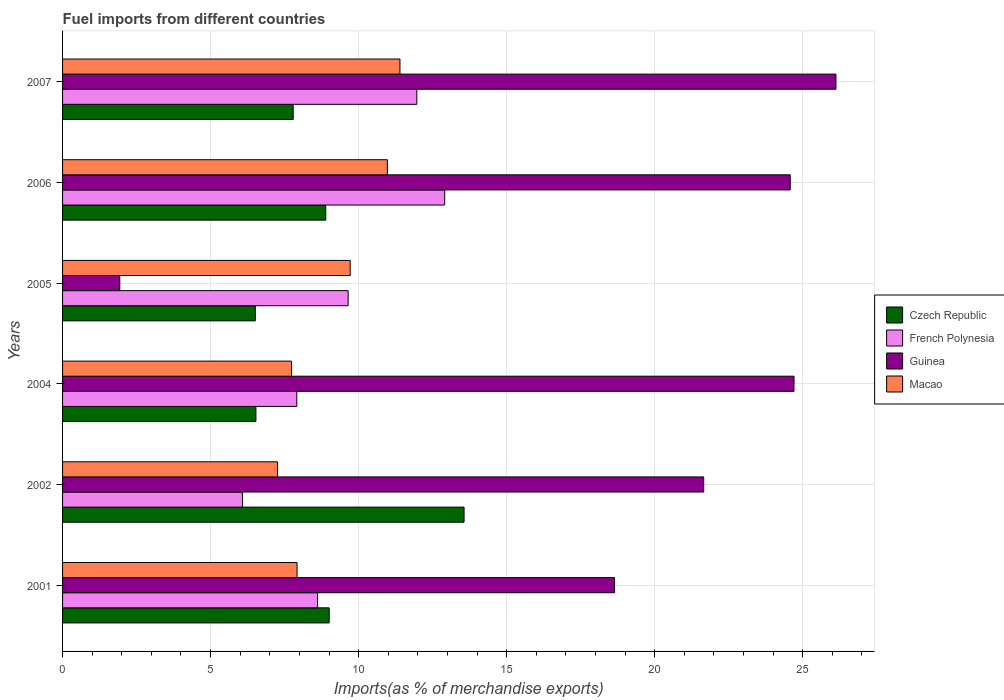How many groups of bars are there?
Your response must be concise. 6. Are the number of bars per tick equal to the number of legend labels?
Provide a short and direct response. Yes. What is the label of the 5th group of bars from the top?
Offer a very short reply. 2002. What is the percentage of imports to different countries in Macao in 2007?
Provide a succinct answer. 11.4. Across all years, what is the maximum percentage of imports to different countries in Guinea?
Your answer should be very brief. 26.12. Across all years, what is the minimum percentage of imports to different countries in Czech Republic?
Keep it short and to the point. 6.51. In which year was the percentage of imports to different countries in Czech Republic maximum?
Your answer should be compact. 2002. In which year was the percentage of imports to different countries in Czech Republic minimum?
Ensure brevity in your answer.  2005. What is the total percentage of imports to different countries in Guinea in the graph?
Ensure brevity in your answer.  117.65. What is the difference between the percentage of imports to different countries in Czech Republic in 2001 and that in 2005?
Offer a terse response. 2.5. What is the difference between the percentage of imports to different countries in Czech Republic in 2006 and the percentage of imports to different countries in French Polynesia in 2002?
Keep it short and to the point. 2.81. What is the average percentage of imports to different countries in French Polynesia per year?
Offer a very short reply. 9.52. In the year 2002, what is the difference between the percentage of imports to different countries in Macao and percentage of imports to different countries in Czech Republic?
Offer a very short reply. -6.3. In how many years, is the percentage of imports to different countries in French Polynesia greater than 16 %?
Give a very brief answer. 0. What is the ratio of the percentage of imports to different countries in Czech Republic in 2001 to that in 2005?
Keep it short and to the point. 1.38. Is the percentage of imports to different countries in French Polynesia in 2004 less than that in 2007?
Ensure brevity in your answer.  Yes. Is the difference between the percentage of imports to different countries in Macao in 2001 and 2006 greater than the difference between the percentage of imports to different countries in Czech Republic in 2001 and 2006?
Give a very brief answer. No. What is the difference between the highest and the second highest percentage of imports to different countries in Guinea?
Keep it short and to the point. 1.42. What is the difference between the highest and the lowest percentage of imports to different countries in Guinea?
Ensure brevity in your answer.  24.19. In how many years, is the percentage of imports to different countries in Macao greater than the average percentage of imports to different countries in Macao taken over all years?
Keep it short and to the point. 3. What does the 2nd bar from the top in 2002 represents?
Your answer should be compact. Guinea. What does the 4th bar from the bottom in 2004 represents?
Keep it short and to the point. Macao. Is it the case that in every year, the sum of the percentage of imports to different countries in Guinea and percentage of imports to different countries in Czech Republic is greater than the percentage of imports to different countries in French Polynesia?
Provide a succinct answer. No. What is the difference between two consecutive major ticks on the X-axis?
Give a very brief answer. 5. Are the values on the major ticks of X-axis written in scientific E-notation?
Your answer should be very brief. No. Where does the legend appear in the graph?
Provide a succinct answer. Center right. How are the legend labels stacked?
Give a very brief answer. Vertical. What is the title of the graph?
Give a very brief answer. Fuel imports from different countries. What is the label or title of the X-axis?
Ensure brevity in your answer.  Imports(as % of merchandise exports). What is the label or title of the Y-axis?
Offer a very short reply. Years. What is the Imports(as % of merchandise exports) in Czech Republic in 2001?
Make the answer very short. 9.01. What is the Imports(as % of merchandise exports) in French Polynesia in 2001?
Make the answer very short. 8.61. What is the Imports(as % of merchandise exports) in Guinea in 2001?
Your answer should be very brief. 18.65. What is the Imports(as % of merchandise exports) in Macao in 2001?
Give a very brief answer. 7.92. What is the Imports(as % of merchandise exports) in Czech Republic in 2002?
Ensure brevity in your answer.  13.56. What is the Imports(as % of merchandise exports) of French Polynesia in 2002?
Provide a short and direct response. 6.08. What is the Imports(as % of merchandise exports) in Guinea in 2002?
Your answer should be very brief. 21.66. What is the Imports(as % of merchandise exports) of Macao in 2002?
Your response must be concise. 7.26. What is the Imports(as % of merchandise exports) of Czech Republic in 2004?
Provide a short and direct response. 6.53. What is the Imports(as % of merchandise exports) of French Polynesia in 2004?
Keep it short and to the point. 7.91. What is the Imports(as % of merchandise exports) of Guinea in 2004?
Your answer should be very brief. 24.71. What is the Imports(as % of merchandise exports) in Macao in 2004?
Make the answer very short. 7.74. What is the Imports(as % of merchandise exports) in Czech Republic in 2005?
Ensure brevity in your answer.  6.51. What is the Imports(as % of merchandise exports) in French Polynesia in 2005?
Offer a terse response. 9.65. What is the Imports(as % of merchandise exports) in Guinea in 2005?
Ensure brevity in your answer.  1.93. What is the Imports(as % of merchandise exports) in Macao in 2005?
Make the answer very short. 9.72. What is the Imports(as % of merchandise exports) of Czech Republic in 2006?
Your answer should be very brief. 8.89. What is the Imports(as % of merchandise exports) of French Polynesia in 2006?
Make the answer very short. 12.91. What is the Imports(as % of merchandise exports) in Guinea in 2006?
Provide a succinct answer. 24.58. What is the Imports(as % of merchandise exports) in Macao in 2006?
Provide a succinct answer. 10.97. What is the Imports(as % of merchandise exports) of Czech Republic in 2007?
Your response must be concise. 7.79. What is the Imports(as % of merchandise exports) of French Polynesia in 2007?
Your answer should be very brief. 11.97. What is the Imports(as % of merchandise exports) in Guinea in 2007?
Offer a terse response. 26.12. What is the Imports(as % of merchandise exports) of Macao in 2007?
Provide a succinct answer. 11.4. Across all years, what is the maximum Imports(as % of merchandise exports) of Czech Republic?
Provide a short and direct response. 13.56. Across all years, what is the maximum Imports(as % of merchandise exports) of French Polynesia?
Offer a terse response. 12.91. Across all years, what is the maximum Imports(as % of merchandise exports) in Guinea?
Offer a very short reply. 26.12. Across all years, what is the maximum Imports(as % of merchandise exports) of Macao?
Ensure brevity in your answer.  11.4. Across all years, what is the minimum Imports(as % of merchandise exports) of Czech Republic?
Give a very brief answer. 6.51. Across all years, what is the minimum Imports(as % of merchandise exports) of French Polynesia?
Offer a very short reply. 6.08. Across all years, what is the minimum Imports(as % of merchandise exports) of Guinea?
Make the answer very short. 1.93. Across all years, what is the minimum Imports(as % of merchandise exports) in Macao?
Your response must be concise. 7.26. What is the total Imports(as % of merchandise exports) of Czech Republic in the graph?
Keep it short and to the point. 52.29. What is the total Imports(as % of merchandise exports) of French Polynesia in the graph?
Provide a short and direct response. 57.12. What is the total Imports(as % of merchandise exports) in Guinea in the graph?
Offer a terse response. 117.65. What is the total Imports(as % of merchandise exports) of Macao in the graph?
Your response must be concise. 55. What is the difference between the Imports(as % of merchandise exports) of Czech Republic in 2001 and that in 2002?
Provide a succinct answer. -4.56. What is the difference between the Imports(as % of merchandise exports) in French Polynesia in 2001 and that in 2002?
Keep it short and to the point. 2.54. What is the difference between the Imports(as % of merchandise exports) of Guinea in 2001 and that in 2002?
Your response must be concise. -3.01. What is the difference between the Imports(as % of merchandise exports) of Macao in 2001 and that in 2002?
Provide a short and direct response. 0.66. What is the difference between the Imports(as % of merchandise exports) of Czech Republic in 2001 and that in 2004?
Provide a succinct answer. 2.48. What is the difference between the Imports(as % of merchandise exports) in French Polynesia in 2001 and that in 2004?
Keep it short and to the point. 0.7. What is the difference between the Imports(as % of merchandise exports) of Guinea in 2001 and that in 2004?
Provide a succinct answer. -6.06. What is the difference between the Imports(as % of merchandise exports) of Macao in 2001 and that in 2004?
Your response must be concise. 0.18. What is the difference between the Imports(as % of merchandise exports) in Czech Republic in 2001 and that in 2005?
Keep it short and to the point. 2.5. What is the difference between the Imports(as % of merchandise exports) in French Polynesia in 2001 and that in 2005?
Your answer should be compact. -1.03. What is the difference between the Imports(as % of merchandise exports) in Guinea in 2001 and that in 2005?
Give a very brief answer. 16.71. What is the difference between the Imports(as % of merchandise exports) in Macao in 2001 and that in 2005?
Offer a terse response. -1.79. What is the difference between the Imports(as % of merchandise exports) of Czech Republic in 2001 and that in 2006?
Make the answer very short. 0.12. What is the difference between the Imports(as % of merchandise exports) in French Polynesia in 2001 and that in 2006?
Keep it short and to the point. -4.3. What is the difference between the Imports(as % of merchandise exports) in Guinea in 2001 and that in 2006?
Keep it short and to the point. -5.93. What is the difference between the Imports(as % of merchandise exports) in Macao in 2001 and that in 2006?
Keep it short and to the point. -3.05. What is the difference between the Imports(as % of merchandise exports) of Czech Republic in 2001 and that in 2007?
Provide a succinct answer. 1.22. What is the difference between the Imports(as % of merchandise exports) in French Polynesia in 2001 and that in 2007?
Give a very brief answer. -3.35. What is the difference between the Imports(as % of merchandise exports) of Guinea in 2001 and that in 2007?
Keep it short and to the point. -7.48. What is the difference between the Imports(as % of merchandise exports) in Macao in 2001 and that in 2007?
Your response must be concise. -3.48. What is the difference between the Imports(as % of merchandise exports) of Czech Republic in 2002 and that in 2004?
Your answer should be compact. 7.03. What is the difference between the Imports(as % of merchandise exports) of French Polynesia in 2002 and that in 2004?
Ensure brevity in your answer.  -1.83. What is the difference between the Imports(as % of merchandise exports) of Guinea in 2002 and that in 2004?
Provide a short and direct response. -3.05. What is the difference between the Imports(as % of merchandise exports) in Macao in 2002 and that in 2004?
Your answer should be compact. -0.47. What is the difference between the Imports(as % of merchandise exports) of Czech Republic in 2002 and that in 2005?
Keep it short and to the point. 7.05. What is the difference between the Imports(as % of merchandise exports) in French Polynesia in 2002 and that in 2005?
Offer a terse response. -3.57. What is the difference between the Imports(as % of merchandise exports) in Guinea in 2002 and that in 2005?
Provide a succinct answer. 19.72. What is the difference between the Imports(as % of merchandise exports) of Macao in 2002 and that in 2005?
Provide a short and direct response. -2.45. What is the difference between the Imports(as % of merchandise exports) of Czech Republic in 2002 and that in 2006?
Make the answer very short. 4.67. What is the difference between the Imports(as % of merchandise exports) in French Polynesia in 2002 and that in 2006?
Keep it short and to the point. -6.83. What is the difference between the Imports(as % of merchandise exports) of Guinea in 2002 and that in 2006?
Provide a short and direct response. -2.92. What is the difference between the Imports(as % of merchandise exports) of Macao in 2002 and that in 2006?
Offer a very short reply. -3.71. What is the difference between the Imports(as % of merchandise exports) of Czech Republic in 2002 and that in 2007?
Keep it short and to the point. 5.77. What is the difference between the Imports(as % of merchandise exports) of French Polynesia in 2002 and that in 2007?
Ensure brevity in your answer.  -5.89. What is the difference between the Imports(as % of merchandise exports) of Guinea in 2002 and that in 2007?
Offer a very short reply. -4.47. What is the difference between the Imports(as % of merchandise exports) in Macao in 2002 and that in 2007?
Offer a terse response. -4.13. What is the difference between the Imports(as % of merchandise exports) of Czech Republic in 2004 and that in 2005?
Keep it short and to the point. 0.02. What is the difference between the Imports(as % of merchandise exports) of French Polynesia in 2004 and that in 2005?
Offer a very short reply. -1.73. What is the difference between the Imports(as % of merchandise exports) in Guinea in 2004 and that in 2005?
Your answer should be very brief. 22.78. What is the difference between the Imports(as % of merchandise exports) of Macao in 2004 and that in 2005?
Offer a very short reply. -1.98. What is the difference between the Imports(as % of merchandise exports) in Czech Republic in 2004 and that in 2006?
Offer a terse response. -2.36. What is the difference between the Imports(as % of merchandise exports) of French Polynesia in 2004 and that in 2006?
Give a very brief answer. -5. What is the difference between the Imports(as % of merchandise exports) of Guinea in 2004 and that in 2006?
Offer a very short reply. 0.13. What is the difference between the Imports(as % of merchandise exports) in Macao in 2004 and that in 2006?
Give a very brief answer. -3.24. What is the difference between the Imports(as % of merchandise exports) of Czech Republic in 2004 and that in 2007?
Ensure brevity in your answer.  -1.26. What is the difference between the Imports(as % of merchandise exports) of French Polynesia in 2004 and that in 2007?
Offer a very short reply. -4.05. What is the difference between the Imports(as % of merchandise exports) in Guinea in 2004 and that in 2007?
Your response must be concise. -1.42. What is the difference between the Imports(as % of merchandise exports) of Macao in 2004 and that in 2007?
Give a very brief answer. -3.66. What is the difference between the Imports(as % of merchandise exports) of Czech Republic in 2005 and that in 2006?
Give a very brief answer. -2.38. What is the difference between the Imports(as % of merchandise exports) of French Polynesia in 2005 and that in 2006?
Make the answer very short. -3.26. What is the difference between the Imports(as % of merchandise exports) of Guinea in 2005 and that in 2006?
Your response must be concise. -22.65. What is the difference between the Imports(as % of merchandise exports) of Macao in 2005 and that in 2006?
Make the answer very short. -1.26. What is the difference between the Imports(as % of merchandise exports) in Czech Republic in 2005 and that in 2007?
Ensure brevity in your answer.  -1.28. What is the difference between the Imports(as % of merchandise exports) of French Polynesia in 2005 and that in 2007?
Your response must be concise. -2.32. What is the difference between the Imports(as % of merchandise exports) of Guinea in 2005 and that in 2007?
Offer a very short reply. -24.19. What is the difference between the Imports(as % of merchandise exports) in Macao in 2005 and that in 2007?
Provide a succinct answer. -1.68. What is the difference between the Imports(as % of merchandise exports) in Czech Republic in 2006 and that in 2007?
Your answer should be very brief. 1.1. What is the difference between the Imports(as % of merchandise exports) of French Polynesia in 2006 and that in 2007?
Offer a terse response. 0.94. What is the difference between the Imports(as % of merchandise exports) of Guinea in 2006 and that in 2007?
Ensure brevity in your answer.  -1.54. What is the difference between the Imports(as % of merchandise exports) of Macao in 2006 and that in 2007?
Your response must be concise. -0.43. What is the difference between the Imports(as % of merchandise exports) in Czech Republic in 2001 and the Imports(as % of merchandise exports) in French Polynesia in 2002?
Make the answer very short. 2.93. What is the difference between the Imports(as % of merchandise exports) of Czech Republic in 2001 and the Imports(as % of merchandise exports) of Guinea in 2002?
Provide a succinct answer. -12.65. What is the difference between the Imports(as % of merchandise exports) in Czech Republic in 2001 and the Imports(as % of merchandise exports) in Macao in 2002?
Provide a succinct answer. 1.74. What is the difference between the Imports(as % of merchandise exports) of French Polynesia in 2001 and the Imports(as % of merchandise exports) of Guinea in 2002?
Keep it short and to the point. -13.04. What is the difference between the Imports(as % of merchandise exports) of French Polynesia in 2001 and the Imports(as % of merchandise exports) of Macao in 2002?
Provide a succinct answer. 1.35. What is the difference between the Imports(as % of merchandise exports) of Guinea in 2001 and the Imports(as % of merchandise exports) of Macao in 2002?
Make the answer very short. 11.38. What is the difference between the Imports(as % of merchandise exports) in Czech Republic in 2001 and the Imports(as % of merchandise exports) in French Polynesia in 2004?
Offer a very short reply. 1.09. What is the difference between the Imports(as % of merchandise exports) in Czech Republic in 2001 and the Imports(as % of merchandise exports) in Guinea in 2004?
Keep it short and to the point. -15.7. What is the difference between the Imports(as % of merchandise exports) in Czech Republic in 2001 and the Imports(as % of merchandise exports) in Macao in 2004?
Your answer should be very brief. 1.27. What is the difference between the Imports(as % of merchandise exports) of French Polynesia in 2001 and the Imports(as % of merchandise exports) of Guinea in 2004?
Provide a succinct answer. -16.1. What is the difference between the Imports(as % of merchandise exports) of French Polynesia in 2001 and the Imports(as % of merchandise exports) of Macao in 2004?
Offer a terse response. 0.88. What is the difference between the Imports(as % of merchandise exports) in Guinea in 2001 and the Imports(as % of merchandise exports) in Macao in 2004?
Make the answer very short. 10.91. What is the difference between the Imports(as % of merchandise exports) in Czech Republic in 2001 and the Imports(as % of merchandise exports) in French Polynesia in 2005?
Your response must be concise. -0.64. What is the difference between the Imports(as % of merchandise exports) in Czech Republic in 2001 and the Imports(as % of merchandise exports) in Guinea in 2005?
Your response must be concise. 7.07. What is the difference between the Imports(as % of merchandise exports) of Czech Republic in 2001 and the Imports(as % of merchandise exports) of Macao in 2005?
Give a very brief answer. -0.71. What is the difference between the Imports(as % of merchandise exports) of French Polynesia in 2001 and the Imports(as % of merchandise exports) of Guinea in 2005?
Offer a very short reply. 6.68. What is the difference between the Imports(as % of merchandise exports) of French Polynesia in 2001 and the Imports(as % of merchandise exports) of Macao in 2005?
Provide a short and direct response. -1.1. What is the difference between the Imports(as % of merchandise exports) of Guinea in 2001 and the Imports(as % of merchandise exports) of Macao in 2005?
Provide a short and direct response. 8.93. What is the difference between the Imports(as % of merchandise exports) in Czech Republic in 2001 and the Imports(as % of merchandise exports) in French Polynesia in 2006?
Make the answer very short. -3.9. What is the difference between the Imports(as % of merchandise exports) in Czech Republic in 2001 and the Imports(as % of merchandise exports) in Guinea in 2006?
Your response must be concise. -15.57. What is the difference between the Imports(as % of merchandise exports) of Czech Republic in 2001 and the Imports(as % of merchandise exports) of Macao in 2006?
Give a very brief answer. -1.96. What is the difference between the Imports(as % of merchandise exports) in French Polynesia in 2001 and the Imports(as % of merchandise exports) in Guinea in 2006?
Make the answer very short. -15.97. What is the difference between the Imports(as % of merchandise exports) of French Polynesia in 2001 and the Imports(as % of merchandise exports) of Macao in 2006?
Provide a succinct answer. -2.36. What is the difference between the Imports(as % of merchandise exports) in Guinea in 2001 and the Imports(as % of merchandise exports) in Macao in 2006?
Keep it short and to the point. 7.67. What is the difference between the Imports(as % of merchandise exports) of Czech Republic in 2001 and the Imports(as % of merchandise exports) of French Polynesia in 2007?
Provide a succinct answer. -2.96. What is the difference between the Imports(as % of merchandise exports) of Czech Republic in 2001 and the Imports(as % of merchandise exports) of Guinea in 2007?
Make the answer very short. -17.12. What is the difference between the Imports(as % of merchandise exports) in Czech Republic in 2001 and the Imports(as % of merchandise exports) in Macao in 2007?
Your response must be concise. -2.39. What is the difference between the Imports(as % of merchandise exports) of French Polynesia in 2001 and the Imports(as % of merchandise exports) of Guinea in 2007?
Give a very brief answer. -17.51. What is the difference between the Imports(as % of merchandise exports) in French Polynesia in 2001 and the Imports(as % of merchandise exports) in Macao in 2007?
Offer a terse response. -2.78. What is the difference between the Imports(as % of merchandise exports) in Guinea in 2001 and the Imports(as % of merchandise exports) in Macao in 2007?
Offer a very short reply. 7.25. What is the difference between the Imports(as % of merchandise exports) of Czech Republic in 2002 and the Imports(as % of merchandise exports) of French Polynesia in 2004?
Provide a short and direct response. 5.65. What is the difference between the Imports(as % of merchandise exports) in Czech Republic in 2002 and the Imports(as % of merchandise exports) in Guinea in 2004?
Make the answer very short. -11.15. What is the difference between the Imports(as % of merchandise exports) in Czech Republic in 2002 and the Imports(as % of merchandise exports) in Macao in 2004?
Provide a short and direct response. 5.83. What is the difference between the Imports(as % of merchandise exports) of French Polynesia in 2002 and the Imports(as % of merchandise exports) of Guinea in 2004?
Provide a short and direct response. -18.63. What is the difference between the Imports(as % of merchandise exports) of French Polynesia in 2002 and the Imports(as % of merchandise exports) of Macao in 2004?
Provide a short and direct response. -1.66. What is the difference between the Imports(as % of merchandise exports) of Guinea in 2002 and the Imports(as % of merchandise exports) of Macao in 2004?
Provide a short and direct response. 13.92. What is the difference between the Imports(as % of merchandise exports) of Czech Republic in 2002 and the Imports(as % of merchandise exports) of French Polynesia in 2005?
Your answer should be compact. 3.92. What is the difference between the Imports(as % of merchandise exports) of Czech Republic in 2002 and the Imports(as % of merchandise exports) of Guinea in 2005?
Offer a terse response. 11.63. What is the difference between the Imports(as % of merchandise exports) of Czech Republic in 2002 and the Imports(as % of merchandise exports) of Macao in 2005?
Offer a terse response. 3.85. What is the difference between the Imports(as % of merchandise exports) in French Polynesia in 2002 and the Imports(as % of merchandise exports) in Guinea in 2005?
Make the answer very short. 4.14. What is the difference between the Imports(as % of merchandise exports) in French Polynesia in 2002 and the Imports(as % of merchandise exports) in Macao in 2005?
Give a very brief answer. -3.64. What is the difference between the Imports(as % of merchandise exports) of Guinea in 2002 and the Imports(as % of merchandise exports) of Macao in 2005?
Give a very brief answer. 11.94. What is the difference between the Imports(as % of merchandise exports) of Czech Republic in 2002 and the Imports(as % of merchandise exports) of French Polynesia in 2006?
Your response must be concise. 0.65. What is the difference between the Imports(as % of merchandise exports) of Czech Republic in 2002 and the Imports(as % of merchandise exports) of Guinea in 2006?
Offer a very short reply. -11.02. What is the difference between the Imports(as % of merchandise exports) in Czech Republic in 2002 and the Imports(as % of merchandise exports) in Macao in 2006?
Give a very brief answer. 2.59. What is the difference between the Imports(as % of merchandise exports) of French Polynesia in 2002 and the Imports(as % of merchandise exports) of Guinea in 2006?
Offer a terse response. -18.5. What is the difference between the Imports(as % of merchandise exports) of French Polynesia in 2002 and the Imports(as % of merchandise exports) of Macao in 2006?
Ensure brevity in your answer.  -4.89. What is the difference between the Imports(as % of merchandise exports) in Guinea in 2002 and the Imports(as % of merchandise exports) in Macao in 2006?
Provide a succinct answer. 10.69. What is the difference between the Imports(as % of merchandise exports) of Czech Republic in 2002 and the Imports(as % of merchandise exports) of French Polynesia in 2007?
Your answer should be very brief. 1.6. What is the difference between the Imports(as % of merchandise exports) in Czech Republic in 2002 and the Imports(as % of merchandise exports) in Guinea in 2007?
Offer a very short reply. -12.56. What is the difference between the Imports(as % of merchandise exports) of Czech Republic in 2002 and the Imports(as % of merchandise exports) of Macao in 2007?
Your response must be concise. 2.17. What is the difference between the Imports(as % of merchandise exports) in French Polynesia in 2002 and the Imports(as % of merchandise exports) in Guinea in 2007?
Provide a short and direct response. -20.05. What is the difference between the Imports(as % of merchandise exports) in French Polynesia in 2002 and the Imports(as % of merchandise exports) in Macao in 2007?
Provide a succinct answer. -5.32. What is the difference between the Imports(as % of merchandise exports) in Guinea in 2002 and the Imports(as % of merchandise exports) in Macao in 2007?
Offer a terse response. 10.26. What is the difference between the Imports(as % of merchandise exports) of Czech Republic in 2004 and the Imports(as % of merchandise exports) of French Polynesia in 2005?
Give a very brief answer. -3.12. What is the difference between the Imports(as % of merchandise exports) in Czech Republic in 2004 and the Imports(as % of merchandise exports) in Guinea in 2005?
Your answer should be very brief. 4.6. What is the difference between the Imports(as % of merchandise exports) of Czech Republic in 2004 and the Imports(as % of merchandise exports) of Macao in 2005?
Keep it short and to the point. -3.18. What is the difference between the Imports(as % of merchandise exports) in French Polynesia in 2004 and the Imports(as % of merchandise exports) in Guinea in 2005?
Ensure brevity in your answer.  5.98. What is the difference between the Imports(as % of merchandise exports) in French Polynesia in 2004 and the Imports(as % of merchandise exports) in Macao in 2005?
Keep it short and to the point. -1.8. What is the difference between the Imports(as % of merchandise exports) of Guinea in 2004 and the Imports(as % of merchandise exports) of Macao in 2005?
Your answer should be compact. 14.99. What is the difference between the Imports(as % of merchandise exports) in Czech Republic in 2004 and the Imports(as % of merchandise exports) in French Polynesia in 2006?
Offer a very short reply. -6.38. What is the difference between the Imports(as % of merchandise exports) in Czech Republic in 2004 and the Imports(as % of merchandise exports) in Guinea in 2006?
Make the answer very short. -18.05. What is the difference between the Imports(as % of merchandise exports) in Czech Republic in 2004 and the Imports(as % of merchandise exports) in Macao in 2006?
Keep it short and to the point. -4.44. What is the difference between the Imports(as % of merchandise exports) in French Polynesia in 2004 and the Imports(as % of merchandise exports) in Guinea in 2006?
Offer a terse response. -16.67. What is the difference between the Imports(as % of merchandise exports) of French Polynesia in 2004 and the Imports(as % of merchandise exports) of Macao in 2006?
Make the answer very short. -3.06. What is the difference between the Imports(as % of merchandise exports) of Guinea in 2004 and the Imports(as % of merchandise exports) of Macao in 2006?
Ensure brevity in your answer.  13.74. What is the difference between the Imports(as % of merchandise exports) in Czech Republic in 2004 and the Imports(as % of merchandise exports) in French Polynesia in 2007?
Provide a short and direct response. -5.43. What is the difference between the Imports(as % of merchandise exports) in Czech Republic in 2004 and the Imports(as % of merchandise exports) in Guinea in 2007?
Your answer should be compact. -19.59. What is the difference between the Imports(as % of merchandise exports) of Czech Republic in 2004 and the Imports(as % of merchandise exports) of Macao in 2007?
Provide a short and direct response. -4.87. What is the difference between the Imports(as % of merchandise exports) of French Polynesia in 2004 and the Imports(as % of merchandise exports) of Guinea in 2007?
Give a very brief answer. -18.21. What is the difference between the Imports(as % of merchandise exports) in French Polynesia in 2004 and the Imports(as % of merchandise exports) in Macao in 2007?
Give a very brief answer. -3.49. What is the difference between the Imports(as % of merchandise exports) in Guinea in 2004 and the Imports(as % of merchandise exports) in Macao in 2007?
Provide a short and direct response. 13.31. What is the difference between the Imports(as % of merchandise exports) in Czech Republic in 2005 and the Imports(as % of merchandise exports) in French Polynesia in 2006?
Your answer should be compact. -6.4. What is the difference between the Imports(as % of merchandise exports) of Czech Republic in 2005 and the Imports(as % of merchandise exports) of Guinea in 2006?
Give a very brief answer. -18.07. What is the difference between the Imports(as % of merchandise exports) in Czech Republic in 2005 and the Imports(as % of merchandise exports) in Macao in 2006?
Ensure brevity in your answer.  -4.46. What is the difference between the Imports(as % of merchandise exports) in French Polynesia in 2005 and the Imports(as % of merchandise exports) in Guinea in 2006?
Ensure brevity in your answer.  -14.93. What is the difference between the Imports(as % of merchandise exports) in French Polynesia in 2005 and the Imports(as % of merchandise exports) in Macao in 2006?
Ensure brevity in your answer.  -1.32. What is the difference between the Imports(as % of merchandise exports) of Guinea in 2005 and the Imports(as % of merchandise exports) of Macao in 2006?
Provide a short and direct response. -9.04. What is the difference between the Imports(as % of merchandise exports) in Czech Republic in 2005 and the Imports(as % of merchandise exports) in French Polynesia in 2007?
Provide a short and direct response. -5.45. What is the difference between the Imports(as % of merchandise exports) in Czech Republic in 2005 and the Imports(as % of merchandise exports) in Guinea in 2007?
Your answer should be compact. -19.61. What is the difference between the Imports(as % of merchandise exports) in Czech Republic in 2005 and the Imports(as % of merchandise exports) in Macao in 2007?
Provide a short and direct response. -4.89. What is the difference between the Imports(as % of merchandise exports) in French Polynesia in 2005 and the Imports(as % of merchandise exports) in Guinea in 2007?
Your answer should be very brief. -16.48. What is the difference between the Imports(as % of merchandise exports) of French Polynesia in 2005 and the Imports(as % of merchandise exports) of Macao in 2007?
Offer a very short reply. -1.75. What is the difference between the Imports(as % of merchandise exports) of Guinea in 2005 and the Imports(as % of merchandise exports) of Macao in 2007?
Your answer should be very brief. -9.46. What is the difference between the Imports(as % of merchandise exports) of Czech Republic in 2006 and the Imports(as % of merchandise exports) of French Polynesia in 2007?
Your response must be concise. -3.08. What is the difference between the Imports(as % of merchandise exports) in Czech Republic in 2006 and the Imports(as % of merchandise exports) in Guinea in 2007?
Offer a very short reply. -17.23. What is the difference between the Imports(as % of merchandise exports) of Czech Republic in 2006 and the Imports(as % of merchandise exports) of Macao in 2007?
Give a very brief answer. -2.51. What is the difference between the Imports(as % of merchandise exports) in French Polynesia in 2006 and the Imports(as % of merchandise exports) in Guinea in 2007?
Give a very brief answer. -13.22. What is the difference between the Imports(as % of merchandise exports) of French Polynesia in 2006 and the Imports(as % of merchandise exports) of Macao in 2007?
Ensure brevity in your answer.  1.51. What is the difference between the Imports(as % of merchandise exports) in Guinea in 2006 and the Imports(as % of merchandise exports) in Macao in 2007?
Your response must be concise. 13.18. What is the average Imports(as % of merchandise exports) in Czech Republic per year?
Make the answer very short. 8.72. What is the average Imports(as % of merchandise exports) of French Polynesia per year?
Your answer should be compact. 9.52. What is the average Imports(as % of merchandise exports) in Guinea per year?
Your response must be concise. 19.61. What is the average Imports(as % of merchandise exports) in Macao per year?
Your response must be concise. 9.17. In the year 2001, what is the difference between the Imports(as % of merchandise exports) of Czech Republic and Imports(as % of merchandise exports) of French Polynesia?
Give a very brief answer. 0.39. In the year 2001, what is the difference between the Imports(as % of merchandise exports) of Czech Republic and Imports(as % of merchandise exports) of Guinea?
Ensure brevity in your answer.  -9.64. In the year 2001, what is the difference between the Imports(as % of merchandise exports) of Czech Republic and Imports(as % of merchandise exports) of Macao?
Provide a short and direct response. 1.09. In the year 2001, what is the difference between the Imports(as % of merchandise exports) in French Polynesia and Imports(as % of merchandise exports) in Guinea?
Give a very brief answer. -10.03. In the year 2001, what is the difference between the Imports(as % of merchandise exports) in French Polynesia and Imports(as % of merchandise exports) in Macao?
Your answer should be very brief. 0.69. In the year 2001, what is the difference between the Imports(as % of merchandise exports) in Guinea and Imports(as % of merchandise exports) in Macao?
Give a very brief answer. 10.73. In the year 2002, what is the difference between the Imports(as % of merchandise exports) of Czech Republic and Imports(as % of merchandise exports) of French Polynesia?
Keep it short and to the point. 7.49. In the year 2002, what is the difference between the Imports(as % of merchandise exports) of Czech Republic and Imports(as % of merchandise exports) of Guinea?
Make the answer very short. -8.09. In the year 2002, what is the difference between the Imports(as % of merchandise exports) in Czech Republic and Imports(as % of merchandise exports) in Macao?
Your answer should be very brief. 6.3. In the year 2002, what is the difference between the Imports(as % of merchandise exports) in French Polynesia and Imports(as % of merchandise exports) in Guinea?
Your response must be concise. -15.58. In the year 2002, what is the difference between the Imports(as % of merchandise exports) in French Polynesia and Imports(as % of merchandise exports) in Macao?
Offer a terse response. -1.19. In the year 2002, what is the difference between the Imports(as % of merchandise exports) of Guinea and Imports(as % of merchandise exports) of Macao?
Make the answer very short. 14.39. In the year 2004, what is the difference between the Imports(as % of merchandise exports) in Czech Republic and Imports(as % of merchandise exports) in French Polynesia?
Give a very brief answer. -1.38. In the year 2004, what is the difference between the Imports(as % of merchandise exports) of Czech Republic and Imports(as % of merchandise exports) of Guinea?
Provide a short and direct response. -18.18. In the year 2004, what is the difference between the Imports(as % of merchandise exports) of Czech Republic and Imports(as % of merchandise exports) of Macao?
Offer a terse response. -1.2. In the year 2004, what is the difference between the Imports(as % of merchandise exports) of French Polynesia and Imports(as % of merchandise exports) of Guinea?
Ensure brevity in your answer.  -16.8. In the year 2004, what is the difference between the Imports(as % of merchandise exports) of French Polynesia and Imports(as % of merchandise exports) of Macao?
Keep it short and to the point. 0.18. In the year 2004, what is the difference between the Imports(as % of merchandise exports) in Guinea and Imports(as % of merchandise exports) in Macao?
Provide a succinct answer. 16.97. In the year 2005, what is the difference between the Imports(as % of merchandise exports) of Czech Republic and Imports(as % of merchandise exports) of French Polynesia?
Your response must be concise. -3.14. In the year 2005, what is the difference between the Imports(as % of merchandise exports) in Czech Republic and Imports(as % of merchandise exports) in Guinea?
Provide a succinct answer. 4.58. In the year 2005, what is the difference between the Imports(as % of merchandise exports) of Czech Republic and Imports(as % of merchandise exports) of Macao?
Make the answer very short. -3.2. In the year 2005, what is the difference between the Imports(as % of merchandise exports) of French Polynesia and Imports(as % of merchandise exports) of Guinea?
Your answer should be compact. 7.71. In the year 2005, what is the difference between the Imports(as % of merchandise exports) in French Polynesia and Imports(as % of merchandise exports) in Macao?
Offer a very short reply. -0.07. In the year 2005, what is the difference between the Imports(as % of merchandise exports) of Guinea and Imports(as % of merchandise exports) of Macao?
Your answer should be very brief. -7.78. In the year 2006, what is the difference between the Imports(as % of merchandise exports) in Czech Republic and Imports(as % of merchandise exports) in French Polynesia?
Keep it short and to the point. -4.02. In the year 2006, what is the difference between the Imports(as % of merchandise exports) of Czech Republic and Imports(as % of merchandise exports) of Guinea?
Offer a terse response. -15.69. In the year 2006, what is the difference between the Imports(as % of merchandise exports) in Czech Republic and Imports(as % of merchandise exports) in Macao?
Ensure brevity in your answer.  -2.08. In the year 2006, what is the difference between the Imports(as % of merchandise exports) of French Polynesia and Imports(as % of merchandise exports) of Guinea?
Give a very brief answer. -11.67. In the year 2006, what is the difference between the Imports(as % of merchandise exports) of French Polynesia and Imports(as % of merchandise exports) of Macao?
Make the answer very short. 1.94. In the year 2006, what is the difference between the Imports(as % of merchandise exports) in Guinea and Imports(as % of merchandise exports) in Macao?
Your response must be concise. 13.61. In the year 2007, what is the difference between the Imports(as % of merchandise exports) in Czech Republic and Imports(as % of merchandise exports) in French Polynesia?
Ensure brevity in your answer.  -4.18. In the year 2007, what is the difference between the Imports(as % of merchandise exports) in Czech Republic and Imports(as % of merchandise exports) in Guinea?
Your answer should be compact. -18.33. In the year 2007, what is the difference between the Imports(as % of merchandise exports) in Czech Republic and Imports(as % of merchandise exports) in Macao?
Ensure brevity in your answer.  -3.61. In the year 2007, what is the difference between the Imports(as % of merchandise exports) of French Polynesia and Imports(as % of merchandise exports) of Guinea?
Offer a terse response. -14.16. In the year 2007, what is the difference between the Imports(as % of merchandise exports) of French Polynesia and Imports(as % of merchandise exports) of Macao?
Give a very brief answer. 0.57. In the year 2007, what is the difference between the Imports(as % of merchandise exports) of Guinea and Imports(as % of merchandise exports) of Macao?
Provide a short and direct response. 14.73. What is the ratio of the Imports(as % of merchandise exports) of Czech Republic in 2001 to that in 2002?
Offer a very short reply. 0.66. What is the ratio of the Imports(as % of merchandise exports) in French Polynesia in 2001 to that in 2002?
Provide a short and direct response. 1.42. What is the ratio of the Imports(as % of merchandise exports) in Guinea in 2001 to that in 2002?
Ensure brevity in your answer.  0.86. What is the ratio of the Imports(as % of merchandise exports) of Macao in 2001 to that in 2002?
Give a very brief answer. 1.09. What is the ratio of the Imports(as % of merchandise exports) in Czech Republic in 2001 to that in 2004?
Offer a very short reply. 1.38. What is the ratio of the Imports(as % of merchandise exports) of French Polynesia in 2001 to that in 2004?
Give a very brief answer. 1.09. What is the ratio of the Imports(as % of merchandise exports) of Guinea in 2001 to that in 2004?
Your answer should be very brief. 0.75. What is the ratio of the Imports(as % of merchandise exports) in Macao in 2001 to that in 2004?
Provide a short and direct response. 1.02. What is the ratio of the Imports(as % of merchandise exports) of Czech Republic in 2001 to that in 2005?
Make the answer very short. 1.38. What is the ratio of the Imports(as % of merchandise exports) of French Polynesia in 2001 to that in 2005?
Your answer should be very brief. 0.89. What is the ratio of the Imports(as % of merchandise exports) of Guinea in 2001 to that in 2005?
Keep it short and to the point. 9.65. What is the ratio of the Imports(as % of merchandise exports) of Macao in 2001 to that in 2005?
Offer a very short reply. 0.82. What is the ratio of the Imports(as % of merchandise exports) in Czech Republic in 2001 to that in 2006?
Ensure brevity in your answer.  1.01. What is the ratio of the Imports(as % of merchandise exports) of French Polynesia in 2001 to that in 2006?
Keep it short and to the point. 0.67. What is the ratio of the Imports(as % of merchandise exports) of Guinea in 2001 to that in 2006?
Provide a succinct answer. 0.76. What is the ratio of the Imports(as % of merchandise exports) in Macao in 2001 to that in 2006?
Your answer should be very brief. 0.72. What is the ratio of the Imports(as % of merchandise exports) in Czech Republic in 2001 to that in 2007?
Make the answer very short. 1.16. What is the ratio of the Imports(as % of merchandise exports) of French Polynesia in 2001 to that in 2007?
Make the answer very short. 0.72. What is the ratio of the Imports(as % of merchandise exports) of Guinea in 2001 to that in 2007?
Keep it short and to the point. 0.71. What is the ratio of the Imports(as % of merchandise exports) of Macao in 2001 to that in 2007?
Provide a short and direct response. 0.69. What is the ratio of the Imports(as % of merchandise exports) in Czech Republic in 2002 to that in 2004?
Keep it short and to the point. 2.08. What is the ratio of the Imports(as % of merchandise exports) in French Polynesia in 2002 to that in 2004?
Ensure brevity in your answer.  0.77. What is the ratio of the Imports(as % of merchandise exports) in Guinea in 2002 to that in 2004?
Ensure brevity in your answer.  0.88. What is the ratio of the Imports(as % of merchandise exports) in Macao in 2002 to that in 2004?
Offer a very short reply. 0.94. What is the ratio of the Imports(as % of merchandise exports) in Czech Republic in 2002 to that in 2005?
Provide a succinct answer. 2.08. What is the ratio of the Imports(as % of merchandise exports) in French Polynesia in 2002 to that in 2005?
Make the answer very short. 0.63. What is the ratio of the Imports(as % of merchandise exports) in Guinea in 2002 to that in 2005?
Offer a terse response. 11.21. What is the ratio of the Imports(as % of merchandise exports) of Macao in 2002 to that in 2005?
Make the answer very short. 0.75. What is the ratio of the Imports(as % of merchandise exports) of Czech Republic in 2002 to that in 2006?
Your response must be concise. 1.53. What is the ratio of the Imports(as % of merchandise exports) in French Polynesia in 2002 to that in 2006?
Keep it short and to the point. 0.47. What is the ratio of the Imports(as % of merchandise exports) in Guinea in 2002 to that in 2006?
Make the answer very short. 0.88. What is the ratio of the Imports(as % of merchandise exports) of Macao in 2002 to that in 2006?
Give a very brief answer. 0.66. What is the ratio of the Imports(as % of merchandise exports) in Czech Republic in 2002 to that in 2007?
Your answer should be compact. 1.74. What is the ratio of the Imports(as % of merchandise exports) of French Polynesia in 2002 to that in 2007?
Your response must be concise. 0.51. What is the ratio of the Imports(as % of merchandise exports) of Guinea in 2002 to that in 2007?
Keep it short and to the point. 0.83. What is the ratio of the Imports(as % of merchandise exports) in Macao in 2002 to that in 2007?
Your answer should be very brief. 0.64. What is the ratio of the Imports(as % of merchandise exports) of French Polynesia in 2004 to that in 2005?
Your answer should be very brief. 0.82. What is the ratio of the Imports(as % of merchandise exports) in Guinea in 2004 to that in 2005?
Keep it short and to the point. 12.79. What is the ratio of the Imports(as % of merchandise exports) of Macao in 2004 to that in 2005?
Provide a short and direct response. 0.8. What is the ratio of the Imports(as % of merchandise exports) in Czech Republic in 2004 to that in 2006?
Make the answer very short. 0.73. What is the ratio of the Imports(as % of merchandise exports) in French Polynesia in 2004 to that in 2006?
Make the answer very short. 0.61. What is the ratio of the Imports(as % of merchandise exports) in Macao in 2004 to that in 2006?
Provide a succinct answer. 0.71. What is the ratio of the Imports(as % of merchandise exports) of Czech Republic in 2004 to that in 2007?
Ensure brevity in your answer.  0.84. What is the ratio of the Imports(as % of merchandise exports) of French Polynesia in 2004 to that in 2007?
Provide a succinct answer. 0.66. What is the ratio of the Imports(as % of merchandise exports) in Guinea in 2004 to that in 2007?
Provide a succinct answer. 0.95. What is the ratio of the Imports(as % of merchandise exports) of Macao in 2004 to that in 2007?
Provide a short and direct response. 0.68. What is the ratio of the Imports(as % of merchandise exports) of Czech Republic in 2005 to that in 2006?
Your answer should be very brief. 0.73. What is the ratio of the Imports(as % of merchandise exports) of French Polynesia in 2005 to that in 2006?
Keep it short and to the point. 0.75. What is the ratio of the Imports(as % of merchandise exports) in Guinea in 2005 to that in 2006?
Your answer should be compact. 0.08. What is the ratio of the Imports(as % of merchandise exports) in Macao in 2005 to that in 2006?
Make the answer very short. 0.89. What is the ratio of the Imports(as % of merchandise exports) of Czech Republic in 2005 to that in 2007?
Keep it short and to the point. 0.84. What is the ratio of the Imports(as % of merchandise exports) in French Polynesia in 2005 to that in 2007?
Offer a very short reply. 0.81. What is the ratio of the Imports(as % of merchandise exports) in Guinea in 2005 to that in 2007?
Ensure brevity in your answer.  0.07. What is the ratio of the Imports(as % of merchandise exports) of Macao in 2005 to that in 2007?
Give a very brief answer. 0.85. What is the ratio of the Imports(as % of merchandise exports) of Czech Republic in 2006 to that in 2007?
Give a very brief answer. 1.14. What is the ratio of the Imports(as % of merchandise exports) in French Polynesia in 2006 to that in 2007?
Provide a succinct answer. 1.08. What is the ratio of the Imports(as % of merchandise exports) of Guinea in 2006 to that in 2007?
Provide a succinct answer. 0.94. What is the ratio of the Imports(as % of merchandise exports) in Macao in 2006 to that in 2007?
Make the answer very short. 0.96. What is the difference between the highest and the second highest Imports(as % of merchandise exports) in Czech Republic?
Offer a very short reply. 4.56. What is the difference between the highest and the second highest Imports(as % of merchandise exports) of French Polynesia?
Your answer should be very brief. 0.94. What is the difference between the highest and the second highest Imports(as % of merchandise exports) of Guinea?
Your answer should be very brief. 1.42. What is the difference between the highest and the second highest Imports(as % of merchandise exports) in Macao?
Give a very brief answer. 0.43. What is the difference between the highest and the lowest Imports(as % of merchandise exports) in Czech Republic?
Your response must be concise. 7.05. What is the difference between the highest and the lowest Imports(as % of merchandise exports) in French Polynesia?
Provide a succinct answer. 6.83. What is the difference between the highest and the lowest Imports(as % of merchandise exports) of Guinea?
Ensure brevity in your answer.  24.19. What is the difference between the highest and the lowest Imports(as % of merchandise exports) in Macao?
Your answer should be compact. 4.13. 